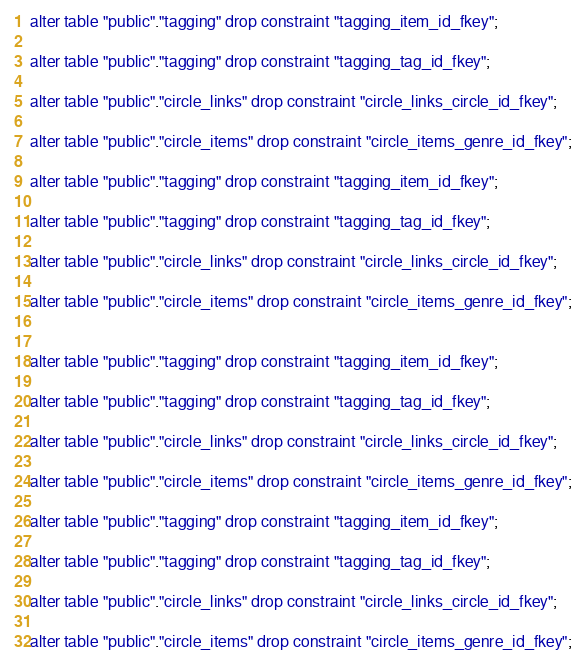Convert code to text. <code><loc_0><loc_0><loc_500><loc_500><_SQL_>


alter table "public"."tagging" drop constraint "tagging_item_id_fkey";

alter table "public"."tagging" drop constraint "tagging_tag_id_fkey";

alter table "public"."circle_links" drop constraint "circle_links_circle_id_fkey";

alter table "public"."circle_items" drop constraint "circle_items_genre_id_fkey";

alter table "public"."tagging" drop constraint "tagging_item_id_fkey";

alter table "public"."tagging" drop constraint "tagging_tag_id_fkey";

alter table "public"."circle_links" drop constraint "circle_links_circle_id_fkey";

alter table "public"."circle_items" drop constraint "circle_items_genre_id_fkey";


alter table "public"."tagging" drop constraint "tagging_item_id_fkey";

alter table "public"."tagging" drop constraint "tagging_tag_id_fkey";

alter table "public"."circle_links" drop constraint "circle_links_circle_id_fkey";

alter table "public"."circle_items" drop constraint "circle_items_genre_id_fkey";

alter table "public"."tagging" drop constraint "tagging_item_id_fkey";

alter table "public"."tagging" drop constraint "tagging_tag_id_fkey";

alter table "public"."circle_links" drop constraint "circle_links_circle_id_fkey";

alter table "public"."circle_items" drop constraint "circle_items_genre_id_fkey";
</code> 